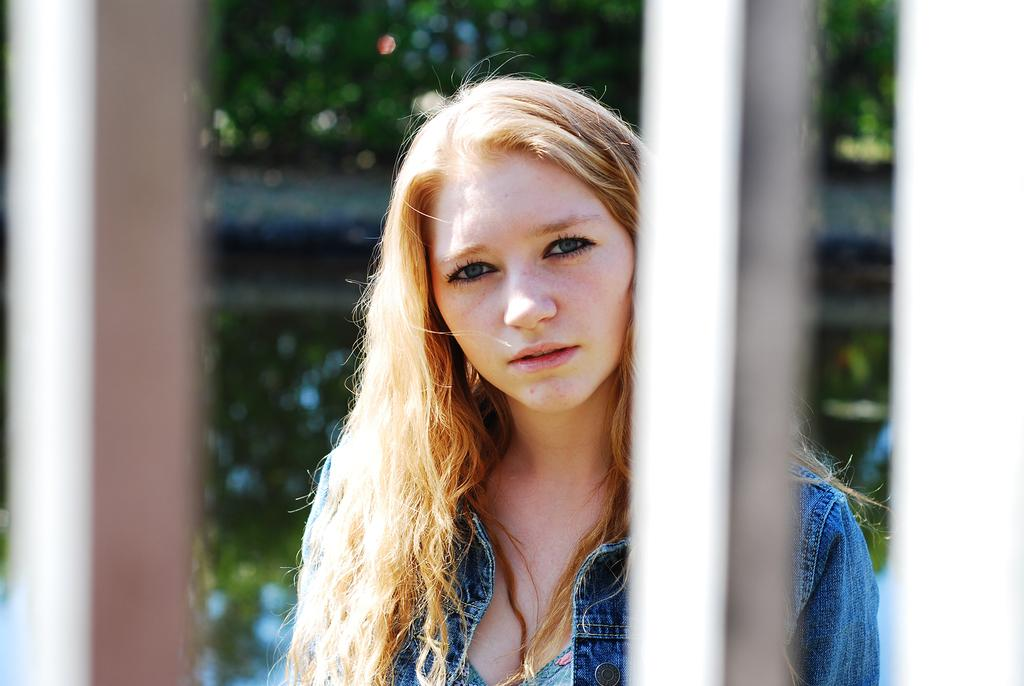Who is the main subject in the image? There is a lady in the center of the image. What can be seen in the background of the image? There are poles and trees in the background of the image. What is visible on the ground in the image? The ground is visible in the background of the image. Is the lady participating in a battle in the image? There is no indication of a battle or any conflict in the image; the lady is simply standing in the center. 